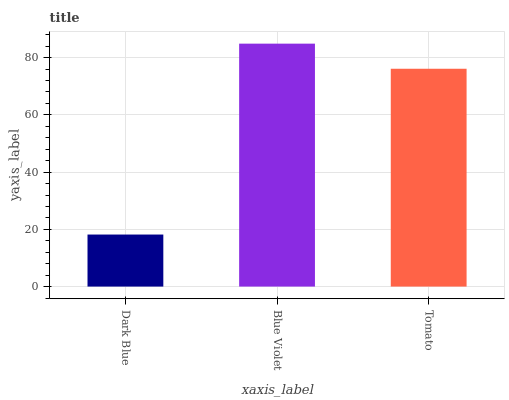Is Dark Blue the minimum?
Answer yes or no. Yes. Is Blue Violet the maximum?
Answer yes or no. Yes. Is Tomato the minimum?
Answer yes or no. No. Is Tomato the maximum?
Answer yes or no. No. Is Blue Violet greater than Tomato?
Answer yes or no. Yes. Is Tomato less than Blue Violet?
Answer yes or no. Yes. Is Tomato greater than Blue Violet?
Answer yes or no. No. Is Blue Violet less than Tomato?
Answer yes or no. No. Is Tomato the high median?
Answer yes or no. Yes. Is Tomato the low median?
Answer yes or no. Yes. Is Dark Blue the high median?
Answer yes or no. No. Is Blue Violet the low median?
Answer yes or no. No. 